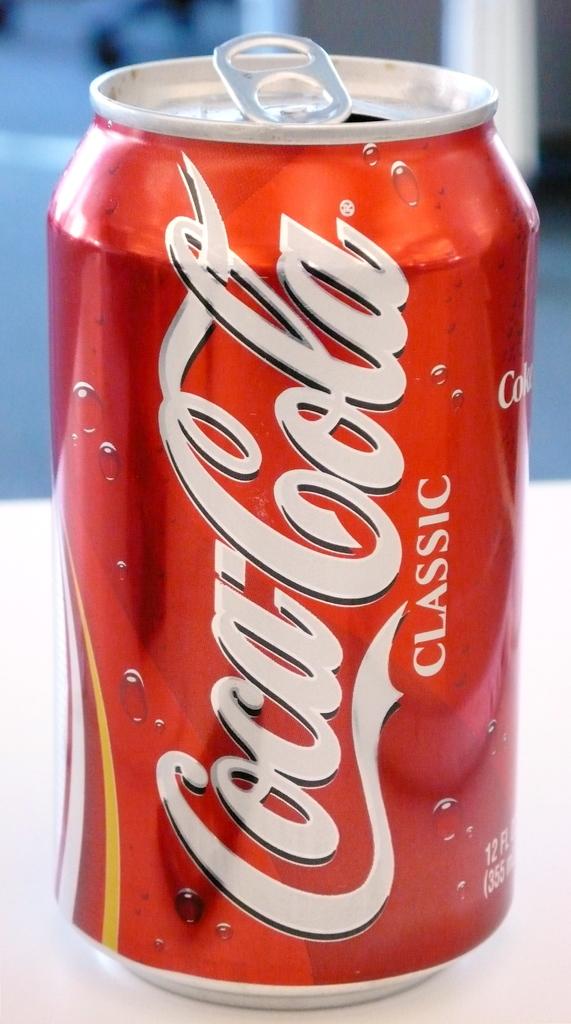What color is this can?
Ensure brevity in your answer.  Answering does not require reading text in the image. 